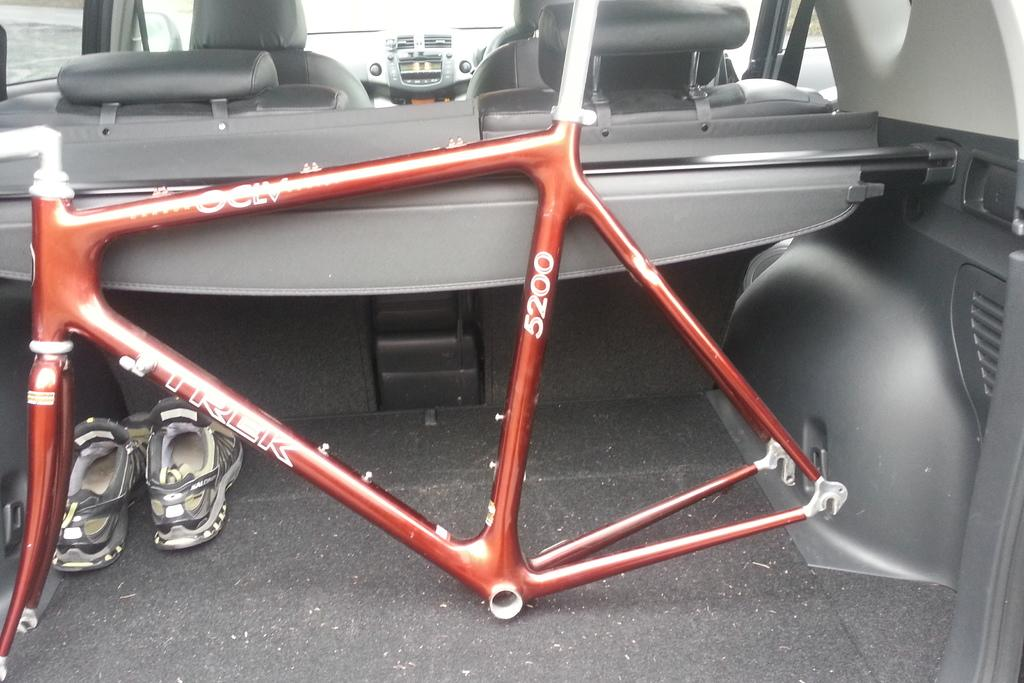What type of space is depicted in the image? The image shows the interior of a vehicle. What specific object related to transportation can be seen in the image? There is a part of a bicycle in the image. What type of personal item is visible in the image? A pair of shoes is visible in the image. Where is the rifle stored in the image? There is no rifle present in the image. What type of bird can be seen perched on the bicycle in the image? There are no birds, including wrens, present in the image. 